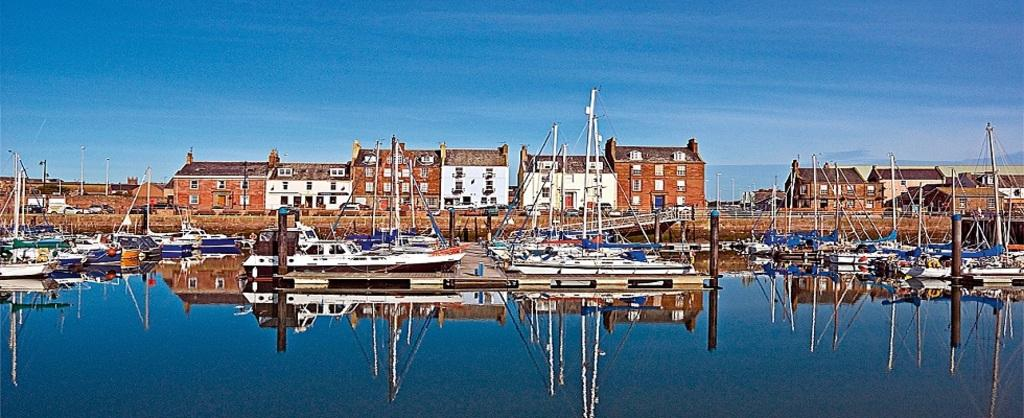What type of vehicles can be seen in the image? There are boats in the image. What structures are present in the image? There are poles and buildings visible in the image. What natural element is featured in the image? There is water visible in the image. What is visible in the background of the image? The sky is visible in the background of the image. What can be observed on the water's surface? There is a reflection on the water. What type of spark can be seen on the stage in the image? There is no stage or spark present in the image. What kind of record is being played on the record player in the image? There is no record player or record present in the image. 